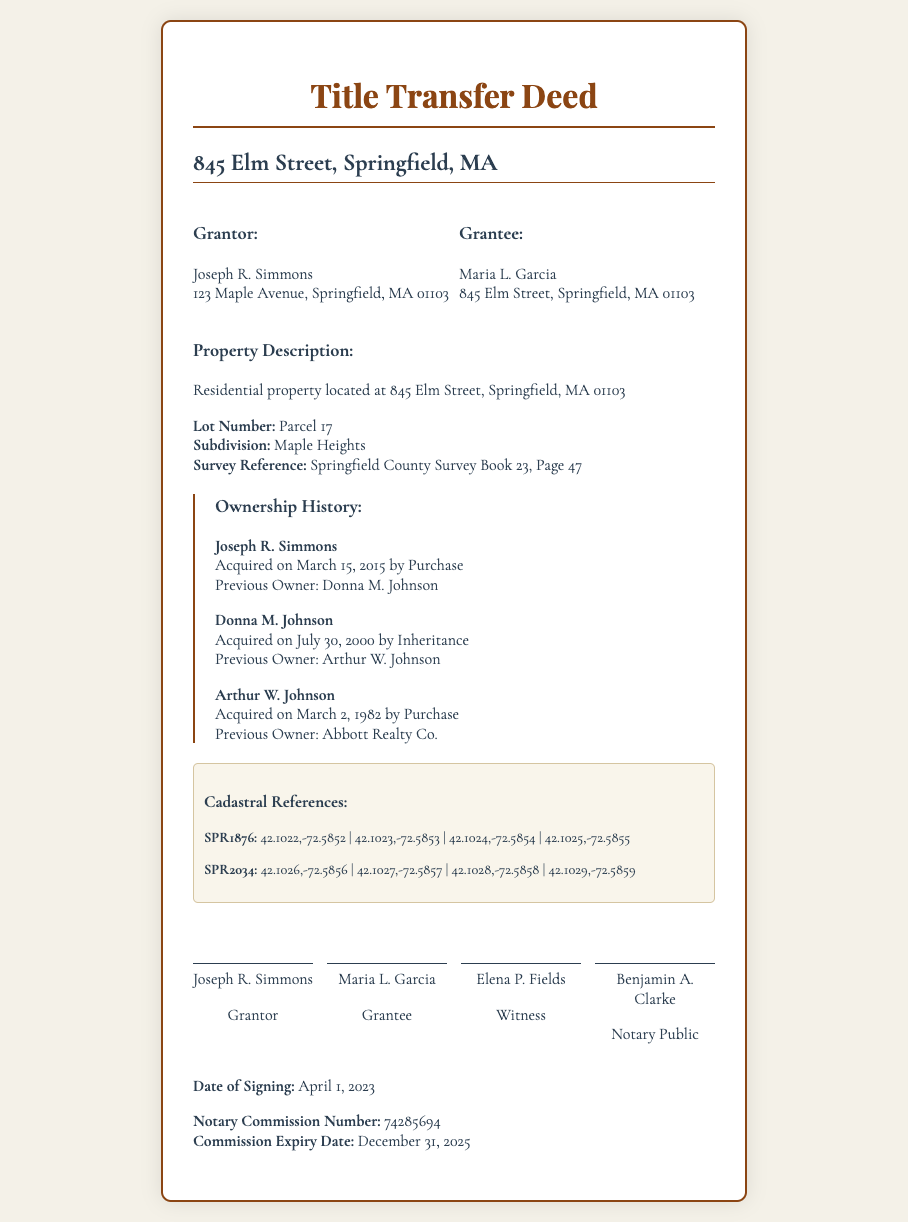What is the address of the property? The property address is specifically mentioned in the document as 845 Elm Street, Springfield, MA 01103.
Answer: 845 Elm Street, Springfield, MA 01103 Who is the grantor? The grantor's name is provided in the document, identifying the person who is transferring the property.
Answer: Joseph R. Simmons What is the date of signing? The document explicitly states the date on which the deed was signed.
Answer: April 1, 2023 What was the previous owner before Joseph R. Simmons? Identifying the predecessor of the current owner in property transfers is critical in ownership history.
Answer: Donna M. Johnson What is the lot number of the property? The document includes specific property details such as the lot number, which is essential for property identification.
Answer: Parcel 17 On what date did Donna M. Johnson acquire the property? This requires referencing the ownership history section in the document which details past acquisitions.
Answer: July 30, 2000 What type of transfer did Arthur W. Johnson use to acquire the property? This question examines the specifics of the ownership history and the method of property acquisition.
Answer: Purchase Who is the notary public? The document lists individuals involved, including the notary, which is essential for verification.
Answer: Benjamin A. Clarke What is the expiry date of the notary commission? This information is necessary for understanding the validity of the notary's authority as stated in the document.
Answer: December 31, 2025 